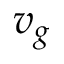<formula> <loc_0><loc_0><loc_500><loc_500>v _ { g }</formula> 